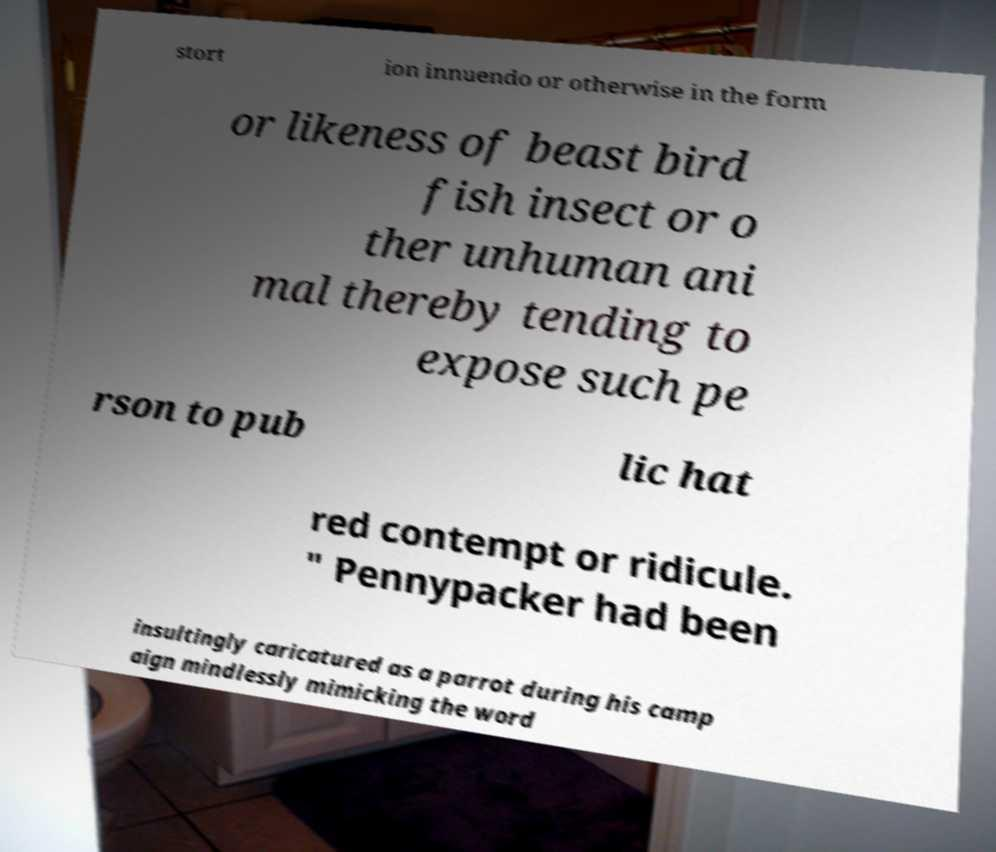Can you read and provide the text displayed in the image?This photo seems to have some interesting text. Can you extract and type it out for me? stort ion innuendo or otherwise in the form or likeness of beast bird fish insect or o ther unhuman ani mal thereby tending to expose such pe rson to pub lic hat red contempt or ridicule. " Pennypacker had been insultingly caricatured as a parrot during his camp aign mindlessly mimicking the word 